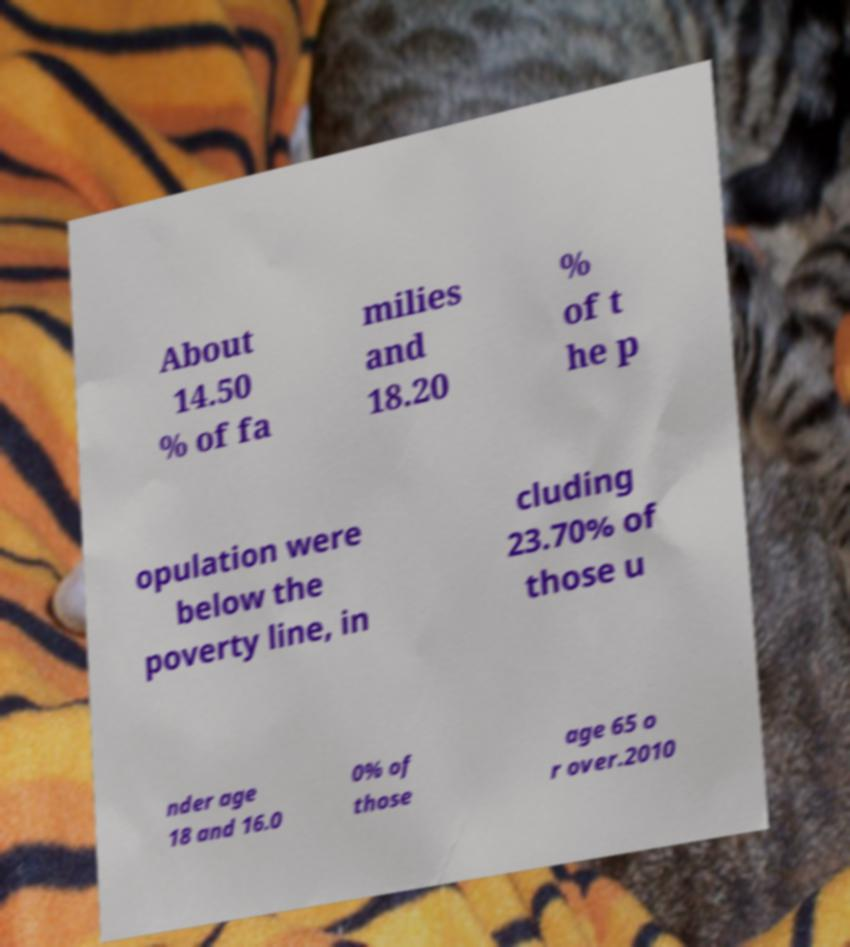There's text embedded in this image that I need extracted. Can you transcribe it verbatim? About 14.50 % of fa milies and 18.20 % of t he p opulation were below the poverty line, in cluding 23.70% of those u nder age 18 and 16.0 0% of those age 65 o r over.2010 